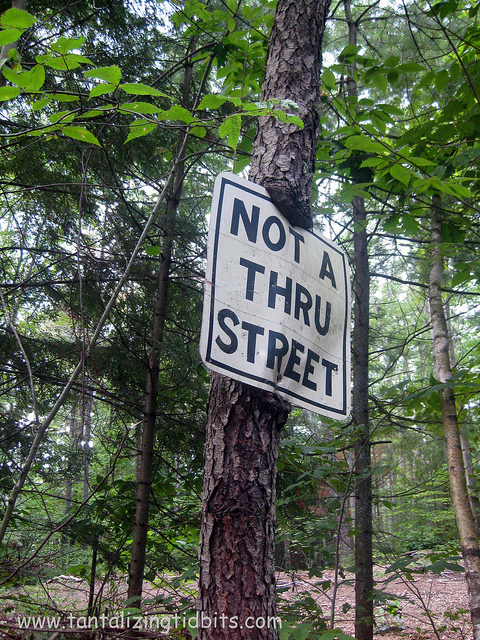Please transcribe the text information in this image. NOT A THRU STREET WWW.TANTALIZINGTIDBITS.COM 